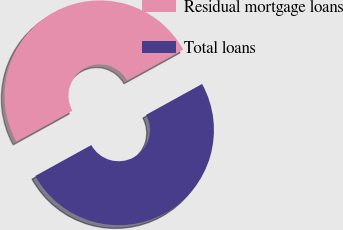Convert chart. <chart><loc_0><loc_0><loc_500><loc_500><pie_chart><fcel>Residual mortgage loans<fcel>Total loans<nl><fcel>50.0%<fcel>50.0%<nl></chart> 